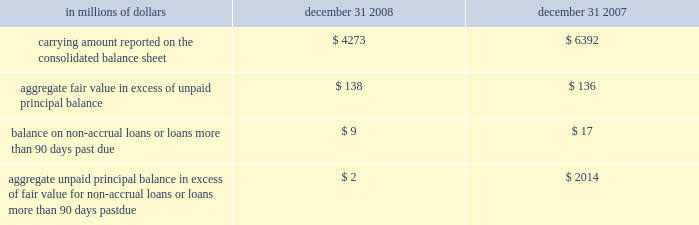The company has elected the fair-value option where the interest-rate risk of such liabilities is economically hedged with derivative contracts or the proceeds are used to purchase financial assets that will also be accounted for at fair value through earnings .
The election has been made to mitigate accounting mismatches and to achieve operational simplifications .
These positions are reported in short-term borrowings and long-term debt on the company 2019s consolidated balance sheet .
The majority of these non-structured liabilities are a result of the company 2019s election of the fair-value option for liabilities associated with the citi-advised structured investment vehicles ( sivs ) , which were consolidated during the fourth quarter of 2007 .
The change in fair values of the sivs 2019 liabilities reported in earnings was $ 2.6 billion for the year ended december 31 , 2008 .
For these non-structured liabilities the aggregate fair value is $ 263 million lower than the aggregate unpaid principal balance as of december 31 , 2008 .
For all other non-structured liabilities classified as long-term debt for which the fair-value option has been elected , the aggregate unpaid principal balance exceeds the aggregate fair value of such instruments by $ 97 million as of december 31 , 2008 while the aggregate fair value exceeded the aggregate unpaid principal by $ 112 million as of december 31 , 2007 .
The change in fair value of these non-structured liabilities reported a gain of $ 1.2 billion for the year ended december 31 , 2008 .
The change in fair value for these non-structured liabilities is reported in principal transactions in the company 2019s consolidated statement of income .
Related interest expense continues to be measured based on the contractual interest rates and reported as such in the consolidated income statement .
Certain mortgage loans citigroup has elected the fair-value option for certain purchased and originated prime fixed-rate and conforming adjustable-rate first mortgage loans held-for- sale .
These loans are intended for sale or securitization and are hedged with derivative instruments .
The company has elected the fair-value option to mitigate accounting mismatches in cases where hedge accounting is complex and to achieve operational simplifications .
The fair-value option was not elected for loans held-for-investment , as those loans are not hedged with derivative instruments .
This election was effective for applicable instruments originated or purchased on or after september 1 , 2007 .
The table provides information about certain mortgage loans carried at fair value : in millions of dollars december 31 , december 31 , carrying amount reported on the consolidated balance sheet $ 4273 $ 6392 aggregate fair value in excess of unpaid principal balance $ 138 $ 136 balance on non-accrual loans or loans more than 90 days past due $ 9 $ 17 aggregate unpaid principal balance in excess of fair value for non-accrual loans or loans more than 90 days past due $ 2 $ 2014 the changes in fair values of these mortgage loans is reported in other revenue in the company 2019s consolidated statement of income .
The changes in fair value during the year ended december 31 , 2008 due to instrument- specific credit risk resulted in a $ 32 million loss .
The change in fair value during 2007 due to instrument-specific credit risk was immaterial .
Related interest income continues to be measured based on the contractual interest rates and reported as such in the consolidated income statement .
Items selected for fair-value accounting in accordance with sfas 155 and sfas 156 certain hybrid financial instruments the company has elected to apply fair-value accounting under sfas 155 for certain hybrid financial assets and liabilities whose performance is linked to risks other than interest rate , foreign exchange or inflation ( e.g. , equity , credit or commodity risks ) .
In addition , the company has elected fair-value accounting under sfas 155 for residual interests retained from securitizing certain financial assets .
The company has elected fair-value accounting for these instruments because these exposures are considered to be trading-related positions and , therefore , are managed on a fair-value basis .
In addition , the accounting for these instruments is simplified under a fair-value approach as it eliminates the complicated operational requirements of bifurcating the embedded derivatives from the host contracts and accounting for each separately .
The hybrid financial instruments are classified as trading account assets , loans , deposits , trading account liabilities ( for prepaid derivatives ) , short-term borrowings or long-term debt on the company 2019s consolidated balance sheet according to their legal form , while residual interests in certain securitizations are classified as trading account assets .
For hybrid financial instruments for which fair-value accounting has been elected under sfas 155 and that are classified as long-term debt , the aggregate unpaid principal exceeds the aggregate fair value by $ 1.9 billion as of december 31 , 2008 , while the aggregate fair value exceeds the aggregate unpaid principal balance by $ 460 million as of december 31 , 2007 .
The difference for those instruments classified as loans is immaterial .
Changes in fair value for hybrid financial instruments , which in most cases includes a component for accrued interest , are recorded in principal transactions in the company 2019s consolidated statement of income .
Interest accruals for certain hybrid instruments classified as trading assets are recorded separately from the change in fair value as interest revenue in the company 2019s consolidated statement of income .
Mortgage servicing rights the company accounts for mortgage servicing rights ( msrs ) at fair value in accordance with sfas 156 .
Fair value for msrs is determined using an option-adjusted spread valuation approach .
This approach consists of projecting servicing cash flows under multiple interest-rate scenarios and discounting these cash flows using risk-adjusted rates .
The model assumptions used in the valuation of msrs include mortgage prepayment speeds and discount rates .
The fair value of msrs is primarily affected by changes in prepayments that result from shifts in mortgage interest rates .
In managing this risk , the company hedges a significant portion of the values of its msrs through the use of interest-rate derivative contracts , forward- purchase commitments of mortgage-backed securities , and purchased securities classified as trading .
See note 23 on page 175 for further discussions regarding the accounting and reporting of msrs .
These msrs , which totaled $ 5.7 billion and $ 8.4 billion as of december 31 , 2008 and december 31 , 2007 , respectively , are classified as mortgage servicing rights on citigroup 2019s consolidated balance sheet .
Changes in fair value of msrs are recorded in commissions and fees in the company 2019s consolidated statement of income. .
The company has elected the fair-value option where the interest-rate risk of such liabilities is economically hedged with derivative contracts or the proceeds are used to purchase financial assets that will also be accounted for at fair value through earnings .
The election has been made to mitigate accounting mismatches and to achieve operational simplifications .
These positions are reported in short-term borrowings and long-term debt on the company 2019s consolidated balance sheet .
The majority of these non-structured liabilities are a result of the company 2019s election of the fair-value option for liabilities associated with the citi-advised structured investment vehicles ( sivs ) , which were consolidated during the fourth quarter of 2007 .
The change in fair values of the sivs 2019 liabilities reported in earnings was $ 2.6 billion for the year ended december 31 , 2008 .
For these non-structured liabilities the aggregate fair value is $ 263 million lower than the aggregate unpaid principal balance as of december 31 , 2008 .
For all other non-structured liabilities classified as long-term debt for which the fair-value option has been elected , the aggregate unpaid principal balance exceeds the aggregate fair value of such instruments by $ 97 million as of december 31 , 2008 while the aggregate fair value exceeded the aggregate unpaid principal by $ 112 million as of december 31 , 2007 .
The change in fair value of these non-structured liabilities reported a gain of $ 1.2 billion for the year ended december 31 , 2008 .
The change in fair value for these non-structured liabilities is reported in principal transactions in the company 2019s consolidated statement of income .
Related interest expense continues to be measured based on the contractual interest rates and reported as such in the consolidated income statement .
Certain mortgage loans citigroup has elected the fair-value option for certain purchased and originated prime fixed-rate and conforming adjustable-rate first mortgage loans held-for- sale .
These loans are intended for sale or securitization and are hedged with derivative instruments .
The company has elected the fair-value option to mitigate accounting mismatches in cases where hedge accounting is complex and to achieve operational simplifications .
The fair-value option was not elected for loans held-for-investment , as those loans are not hedged with derivative instruments .
This election was effective for applicable instruments originated or purchased on or after september 1 , 2007 .
The following table provides information about certain mortgage loans carried at fair value : in millions of dollars december 31 , december 31 , carrying amount reported on the consolidated balance sheet $ 4273 $ 6392 aggregate fair value in excess of unpaid principal balance $ 138 $ 136 balance on non-accrual loans or loans more than 90 days past due $ 9 $ 17 aggregate unpaid principal balance in excess of fair value for non-accrual loans or loans more than 90 days past due $ 2 $ 2014 the changes in fair values of these mortgage loans is reported in other revenue in the company 2019s consolidated statement of income .
The changes in fair value during the year ended december 31 , 2008 due to instrument- specific credit risk resulted in a $ 32 million loss .
The change in fair value during 2007 due to instrument-specific credit risk was immaterial .
Related interest income continues to be measured based on the contractual interest rates and reported as such in the consolidated income statement .
Items selected for fair-value accounting in accordance with sfas 155 and sfas 156 certain hybrid financial instruments the company has elected to apply fair-value accounting under sfas 155 for certain hybrid financial assets and liabilities whose performance is linked to risks other than interest rate , foreign exchange or inflation ( e.g. , equity , credit or commodity risks ) .
In addition , the company has elected fair-value accounting under sfas 155 for residual interests retained from securitizing certain financial assets .
The company has elected fair-value accounting for these instruments because these exposures are considered to be trading-related positions and , therefore , are managed on a fair-value basis .
In addition , the accounting for these instruments is simplified under a fair-value approach as it eliminates the complicated operational requirements of bifurcating the embedded derivatives from the host contracts and accounting for each separately .
The hybrid financial instruments are classified as trading account assets , loans , deposits , trading account liabilities ( for prepaid derivatives ) , short-term borrowings or long-term debt on the company 2019s consolidated balance sheet according to their legal form , while residual interests in certain securitizations are classified as trading account assets .
For hybrid financial instruments for which fair-value accounting has been elected under sfas 155 and that are classified as long-term debt , the aggregate unpaid principal exceeds the aggregate fair value by $ 1.9 billion as of december 31 , 2008 , while the aggregate fair value exceeds the aggregate unpaid principal balance by $ 460 million as of december 31 , 2007 .
The difference for those instruments classified as loans is immaterial .
Changes in fair value for hybrid financial instruments , which in most cases includes a component for accrued interest , are recorded in principal transactions in the company 2019s consolidated statement of income .
Interest accruals for certain hybrid instruments classified as trading assets are recorded separately from the change in fair value as interest revenue in the company 2019s consolidated statement of income .
Mortgage servicing rights the company accounts for mortgage servicing rights ( msrs ) at fair value in accordance with sfas 156 .
Fair value for msrs is determined using an option-adjusted spread valuation approach .
This approach consists of projecting servicing cash flows under multiple interest-rate scenarios and discounting these cash flows using risk-adjusted rates .
The model assumptions used in the valuation of msrs include mortgage prepayment speeds and discount rates .
The fair value of msrs is primarily affected by changes in prepayments that result from shifts in mortgage interest rates .
In managing this risk , the company hedges a significant portion of the values of its msrs through the use of interest-rate derivative contracts , forward- purchase commitments of mortgage-backed securities , and purchased securities classified as trading .
See note 23 on page 175 for further discussions regarding the accounting and reporting of msrs .
These msrs , which totaled $ 5.7 billion and $ 8.4 billion as of december 31 , 2008 and december 31 , 2007 , respectively , are classified as mortgage servicing rights on citigroup 2019s consolidated balance sheet .
Changes in fair value of msrs are recorded in commissions and fees in the company 2019s consolidated statement of income. .
What was the change in millions of the carrying amount reported on the consolidated balance sheet from 2007 to 2008? 
Computations: (4273 - 6392)
Answer: -2119.0. 